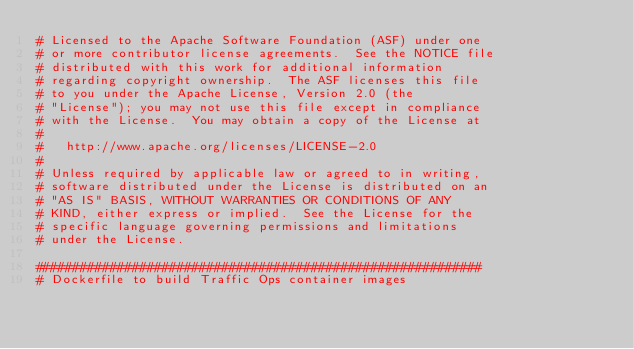<code> <loc_0><loc_0><loc_500><loc_500><_Dockerfile_># Licensed to the Apache Software Foundation (ASF) under one
# or more contributor license agreements.  See the NOTICE file
# distributed with this work for additional information
# regarding copyright ownership.  The ASF licenses this file
# to you under the Apache License, Version 2.0 (the
# "License"); you may not use this file except in compliance
# with the License.  You may obtain a copy of the License at
#
#   http://www.apache.org/licenses/LICENSE-2.0
#
# Unless required by applicable law or agreed to in writing,
# software distributed under the License is distributed on an
# "AS IS" BASIS, WITHOUT WARRANTIES OR CONDITIONS OF ANY
# KIND, either express or implied.  See the License for the
# specific language governing permissions and limitations
# under the License.

############################################################
# Dockerfile to build Traffic Ops container images</code> 